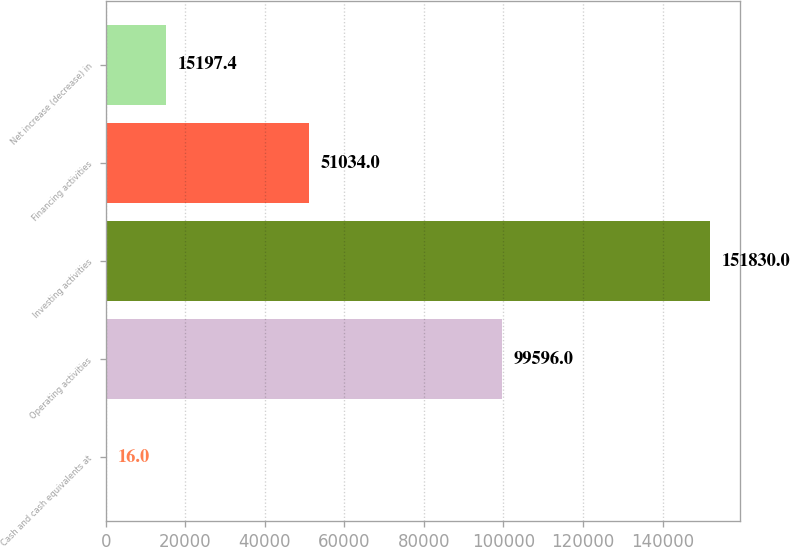Convert chart. <chart><loc_0><loc_0><loc_500><loc_500><bar_chart><fcel>Cash and cash equivalents at<fcel>Operating activities<fcel>Investing activities<fcel>Financing activities<fcel>Net increase (decrease) in<nl><fcel>16<fcel>99596<fcel>151830<fcel>51034<fcel>15197.4<nl></chart> 